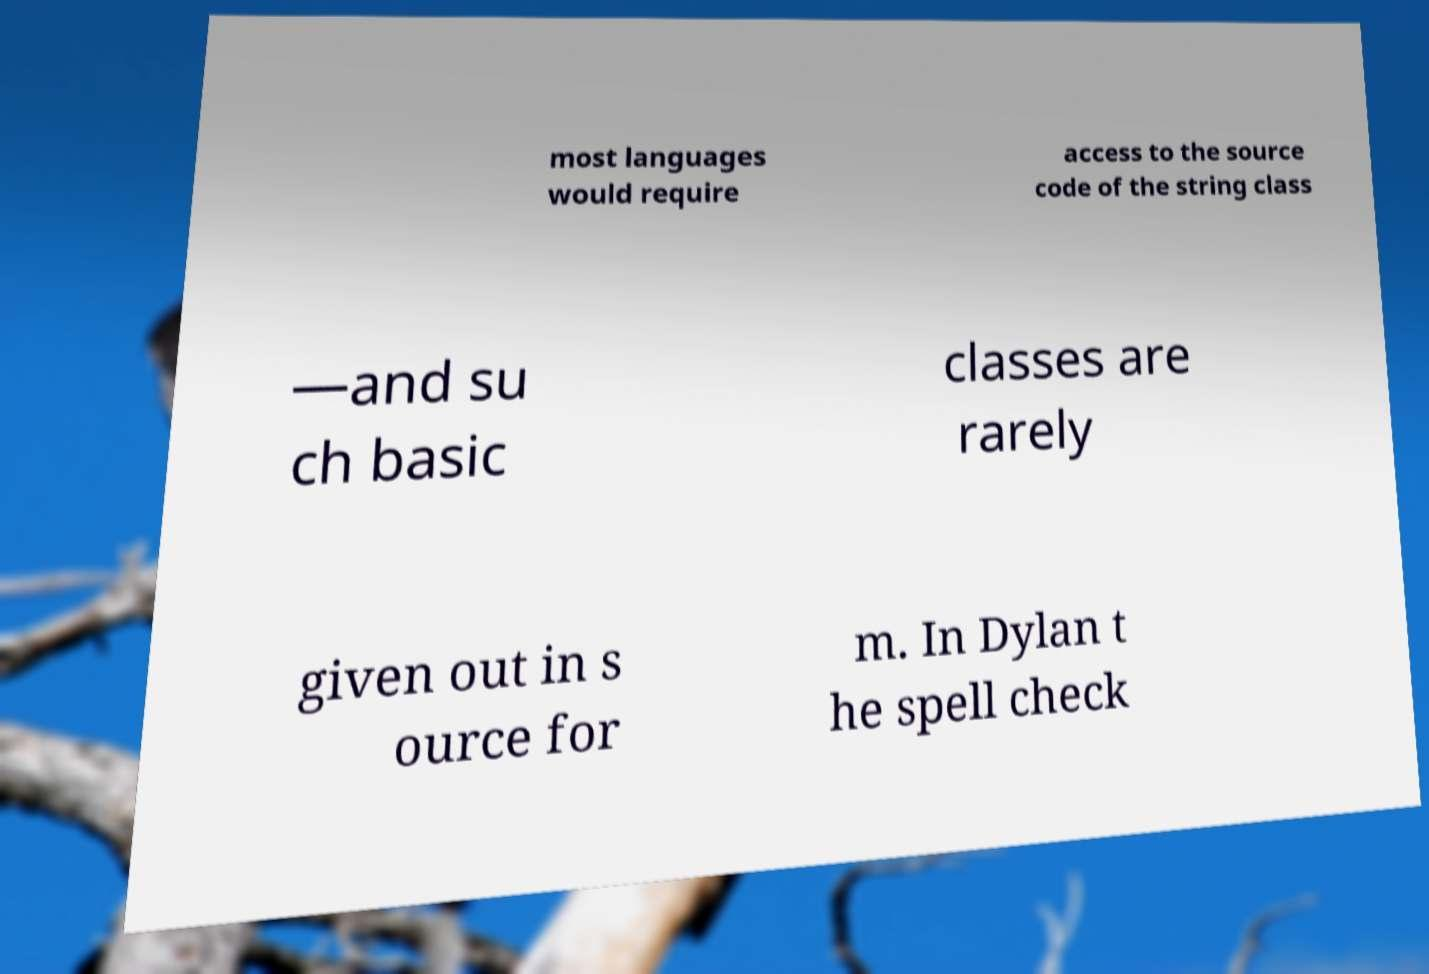Can you read and provide the text displayed in the image?This photo seems to have some interesting text. Can you extract and type it out for me? most languages would require access to the source code of the string class —and su ch basic classes are rarely given out in s ource for m. In Dylan t he spell check 